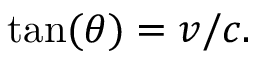Convert formula to latex. <formula><loc_0><loc_0><loc_500><loc_500>\tan ( \theta ) = v / c .</formula> 